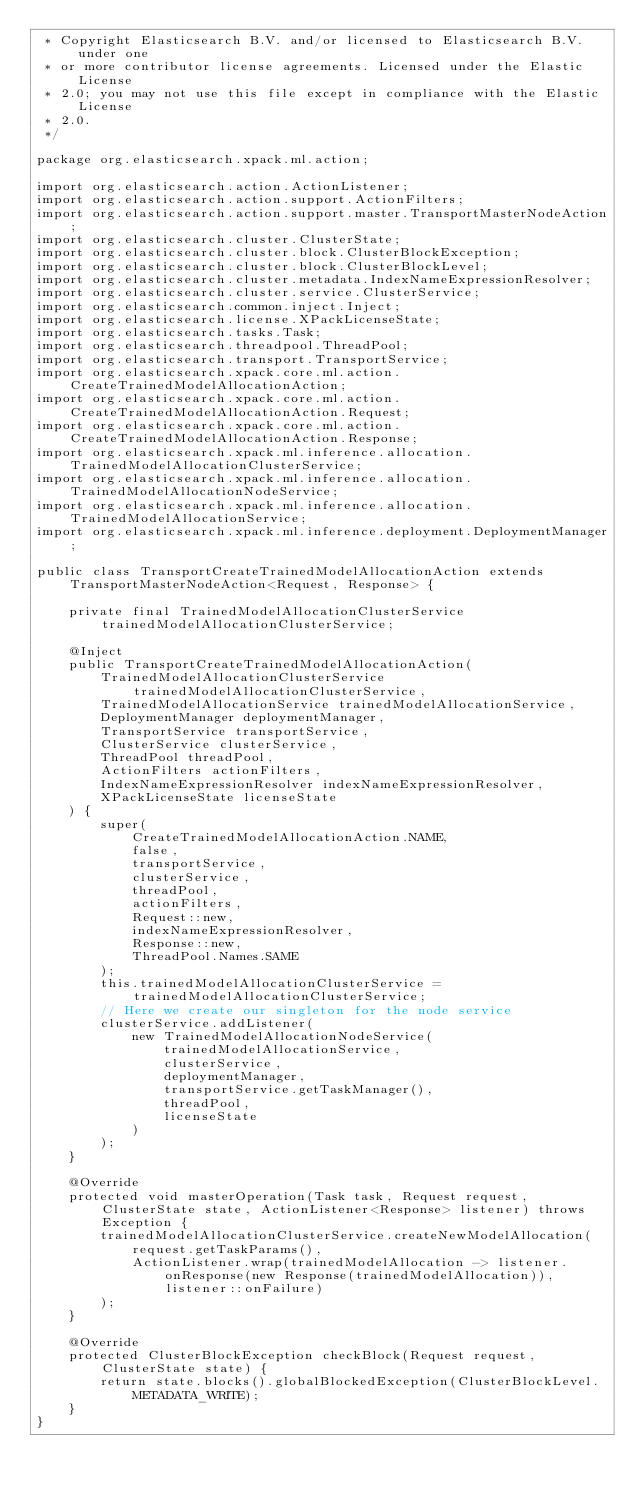Convert code to text. <code><loc_0><loc_0><loc_500><loc_500><_Java_> * Copyright Elasticsearch B.V. and/or licensed to Elasticsearch B.V. under one
 * or more contributor license agreements. Licensed under the Elastic License
 * 2.0; you may not use this file except in compliance with the Elastic License
 * 2.0.
 */

package org.elasticsearch.xpack.ml.action;

import org.elasticsearch.action.ActionListener;
import org.elasticsearch.action.support.ActionFilters;
import org.elasticsearch.action.support.master.TransportMasterNodeAction;
import org.elasticsearch.cluster.ClusterState;
import org.elasticsearch.cluster.block.ClusterBlockException;
import org.elasticsearch.cluster.block.ClusterBlockLevel;
import org.elasticsearch.cluster.metadata.IndexNameExpressionResolver;
import org.elasticsearch.cluster.service.ClusterService;
import org.elasticsearch.common.inject.Inject;
import org.elasticsearch.license.XPackLicenseState;
import org.elasticsearch.tasks.Task;
import org.elasticsearch.threadpool.ThreadPool;
import org.elasticsearch.transport.TransportService;
import org.elasticsearch.xpack.core.ml.action.CreateTrainedModelAllocationAction;
import org.elasticsearch.xpack.core.ml.action.CreateTrainedModelAllocationAction.Request;
import org.elasticsearch.xpack.core.ml.action.CreateTrainedModelAllocationAction.Response;
import org.elasticsearch.xpack.ml.inference.allocation.TrainedModelAllocationClusterService;
import org.elasticsearch.xpack.ml.inference.allocation.TrainedModelAllocationNodeService;
import org.elasticsearch.xpack.ml.inference.allocation.TrainedModelAllocationService;
import org.elasticsearch.xpack.ml.inference.deployment.DeploymentManager;

public class TransportCreateTrainedModelAllocationAction extends TransportMasterNodeAction<Request, Response> {

    private final TrainedModelAllocationClusterService trainedModelAllocationClusterService;

    @Inject
    public TransportCreateTrainedModelAllocationAction(
        TrainedModelAllocationClusterService trainedModelAllocationClusterService,
        TrainedModelAllocationService trainedModelAllocationService,
        DeploymentManager deploymentManager,
        TransportService transportService,
        ClusterService clusterService,
        ThreadPool threadPool,
        ActionFilters actionFilters,
        IndexNameExpressionResolver indexNameExpressionResolver,
        XPackLicenseState licenseState
    ) {
        super(
            CreateTrainedModelAllocationAction.NAME,
            false,
            transportService,
            clusterService,
            threadPool,
            actionFilters,
            Request::new,
            indexNameExpressionResolver,
            Response::new,
            ThreadPool.Names.SAME
        );
        this.trainedModelAllocationClusterService = trainedModelAllocationClusterService;
        // Here we create our singleton for the node service
        clusterService.addListener(
            new TrainedModelAllocationNodeService(
                trainedModelAllocationService,
                clusterService,
                deploymentManager,
                transportService.getTaskManager(),
                threadPool,
                licenseState
            )
        );
    }

    @Override
    protected void masterOperation(Task task, Request request, ClusterState state, ActionListener<Response> listener) throws Exception {
        trainedModelAllocationClusterService.createNewModelAllocation(
            request.getTaskParams(),
            ActionListener.wrap(trainedModelAllocation -> listener.onResponse(new Response(trainedModelAllocation)), listener::onFailure)
        );
    }

    @Override
    protected ClusterBlockException checkBlock(Request request, ClusterState state) {
        return state.blocks().globalBlockedException(ClusterBlockLevel.METADATA_WRITE);
    }
}
</code> 